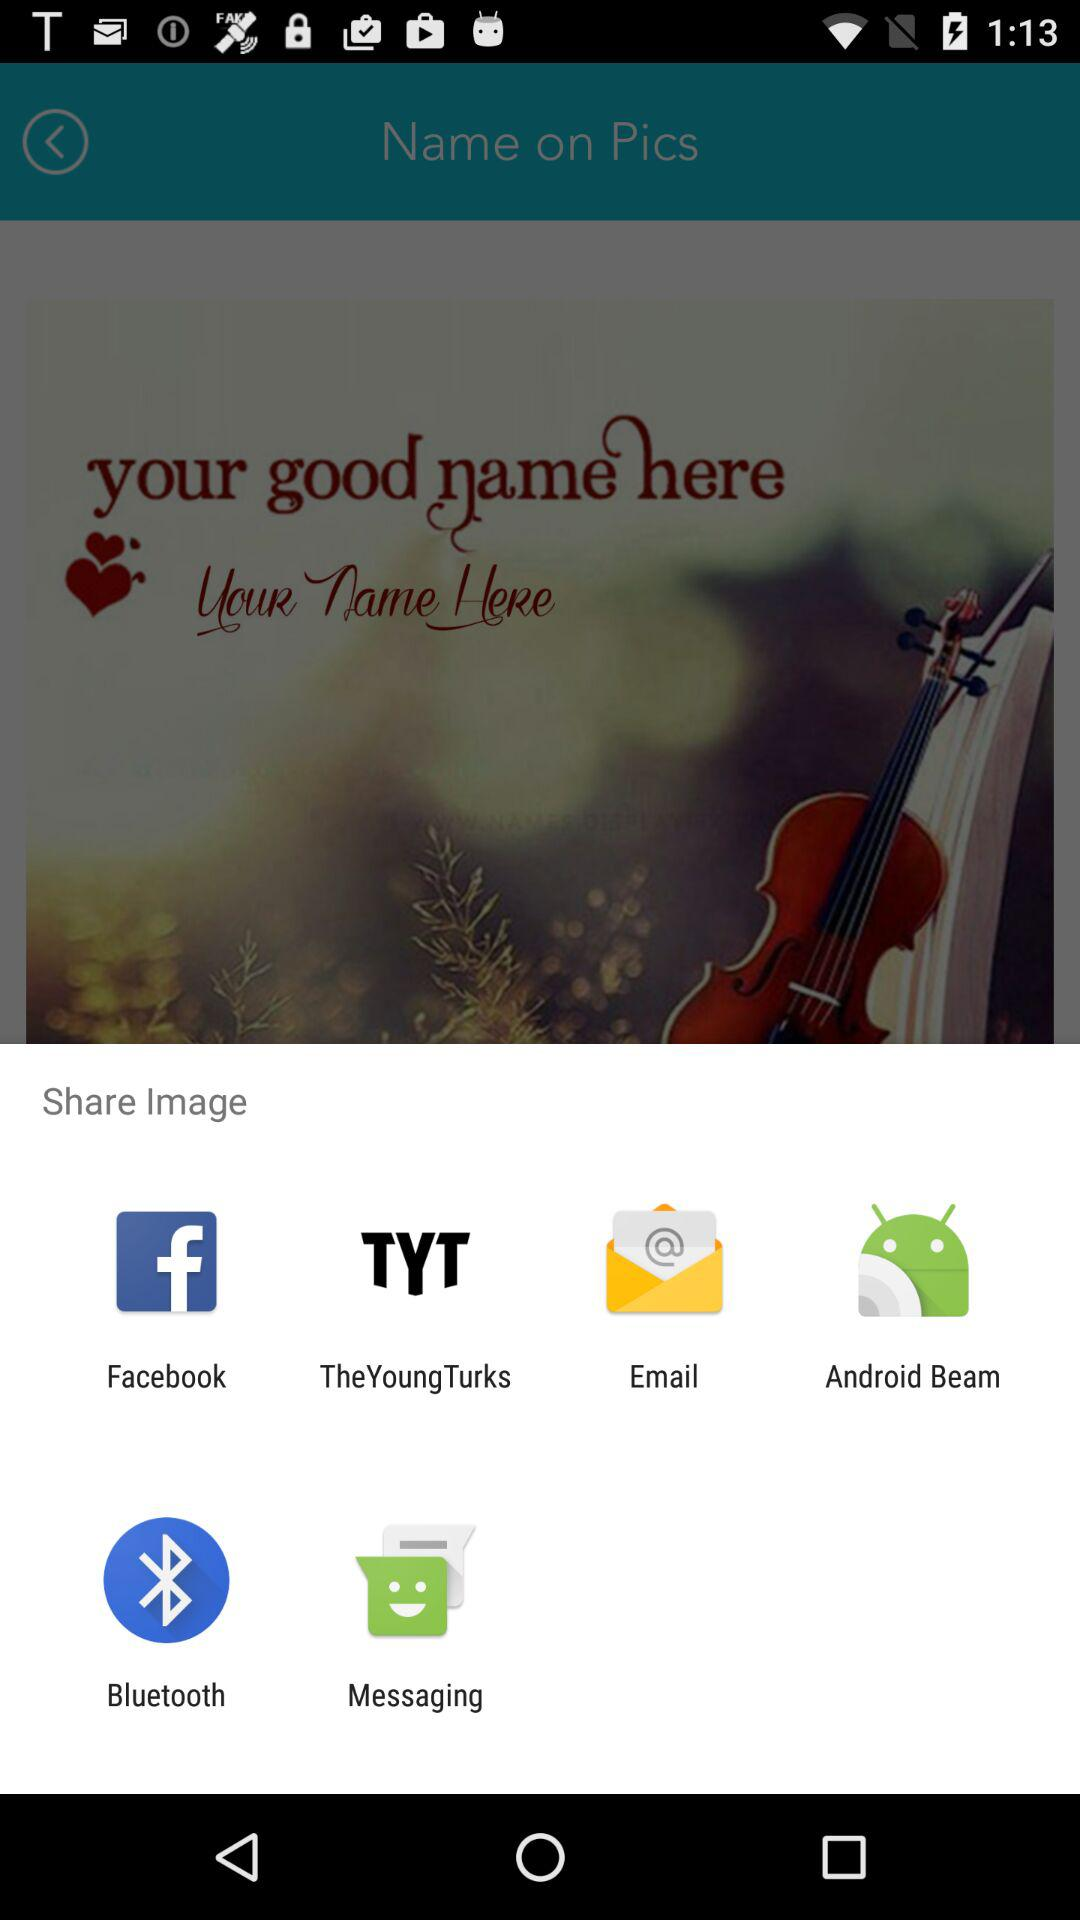Which applications can be used to share the images? The applications that can be used to share the images are "Facebook", "TheYoungTurks", "Email", "Android Beam", "Bluetooth" and "Messaging". 